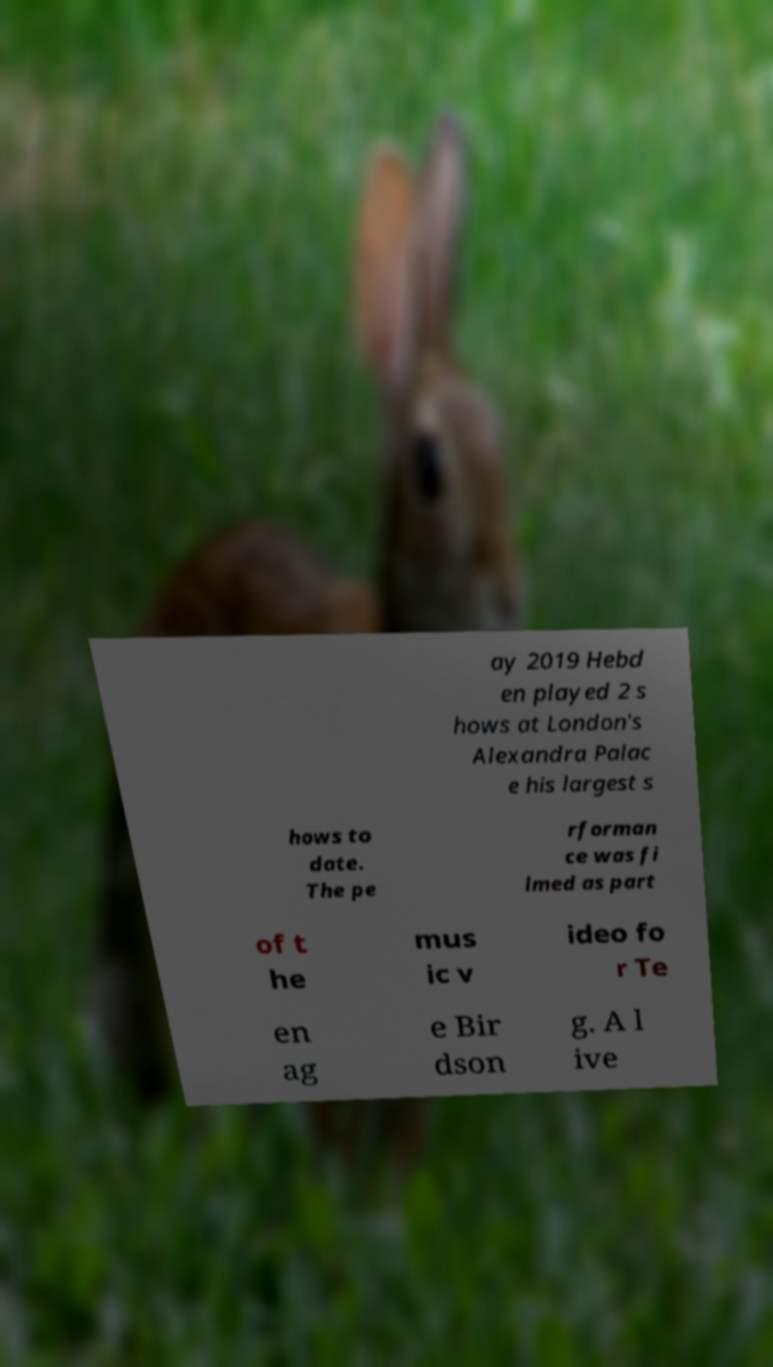Please identify and transcribe the text found in this image. ay 2019 Hebd en played 2 s hows at London's Alexandra Palac e his largest s hows to date. The pe rforman ce was fi lmed as part of t he mus ic v ideo fo r Te en ag e Bir dson g. A l ive 